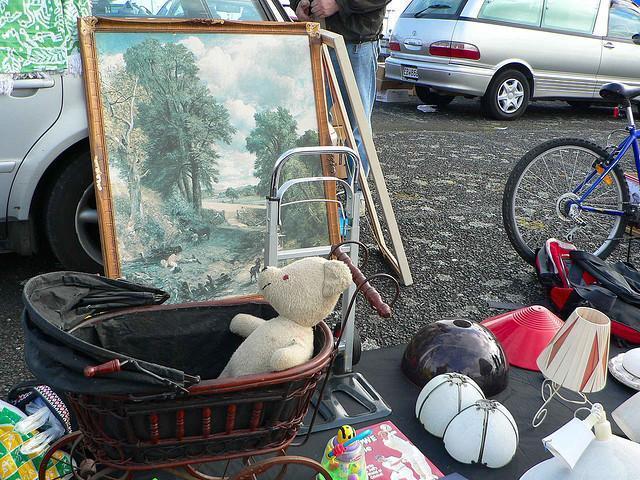How many cars are there?
Give a very brief answer. 2. 